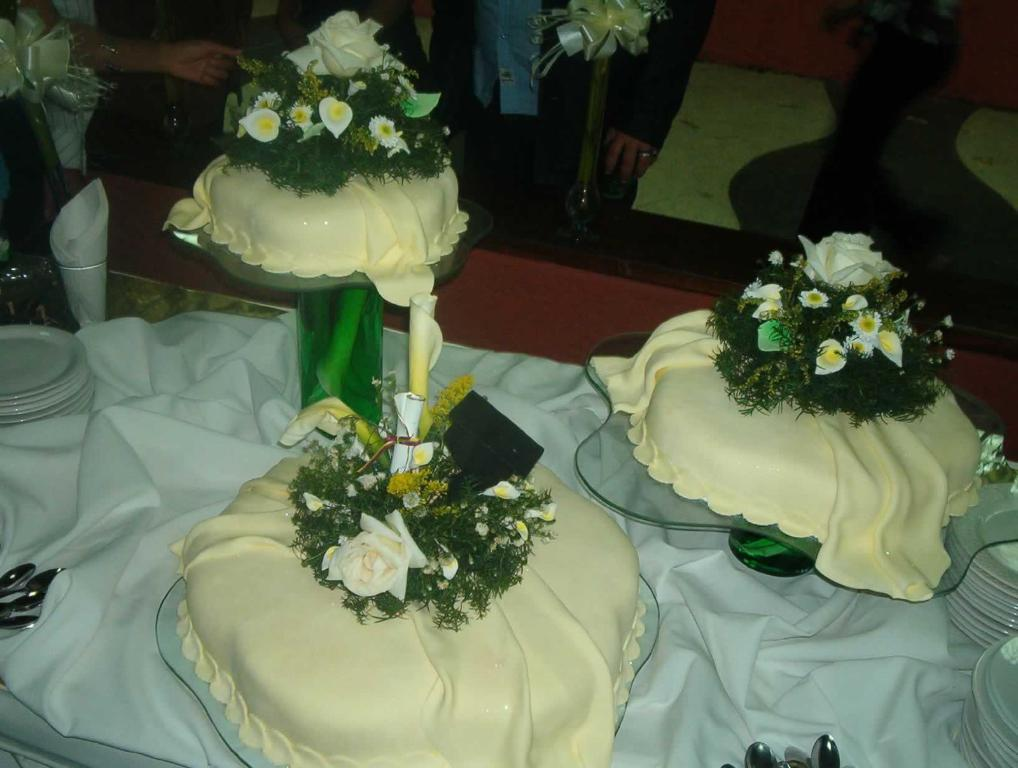Who or what is present in the image? There are people in the image. What can be seen on the glass stands in the image? There are objects on glass stands in the image. What type of decorative item is visible in the image? There are ribbons in the image. What type of dishware is present in the image? There are plates in the image. What utensils can be seen in the image? There are spoons in the image. What type of material is present in the image? There is cloth in the image. What is the cause of the goat's sudden appearance in the image? There is no goat present in the image, so there is no cause for its sudden appearance. 